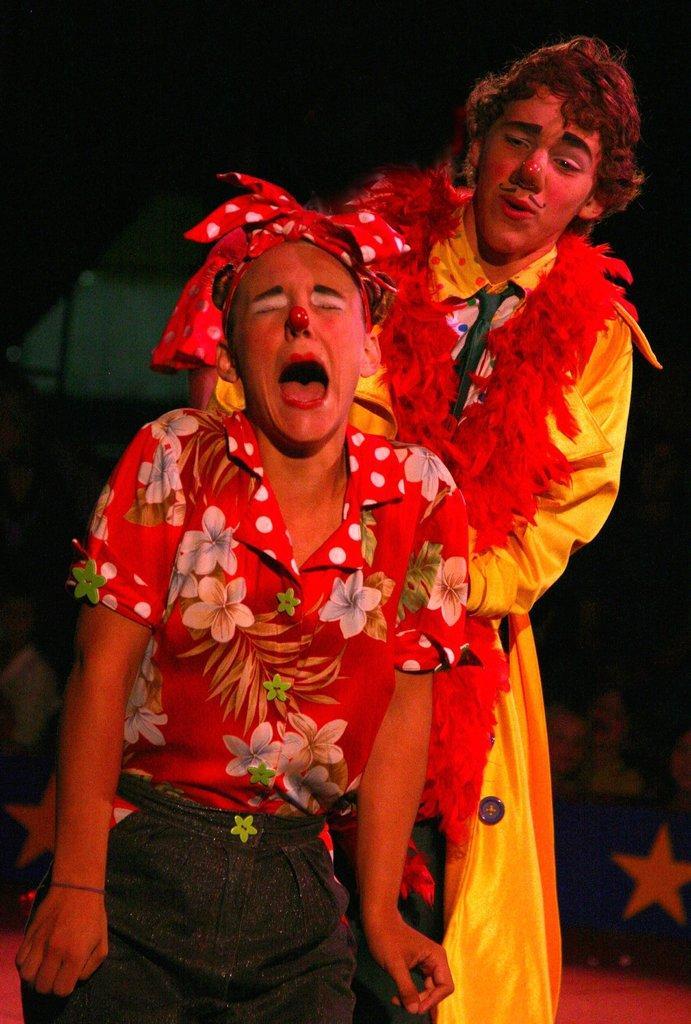How would you summarize this image in a sentence or two? There are two persons. One person is wearing a headband. Other person is wearing a garland. In the background it is blurred and there are few people. 